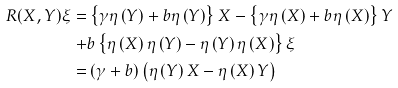Convert formula to latex. <formula><loc_0><loc_0><loc_500><loc_500>R ( X , Y ) \xi = & \left \{ \gamma \eta \left ( Y \right ) + b \eta \left ( Y \right ) \right \} X - \left \{ \gamma \eta \left ( X \right ) + b \eta \left ( X \right ) \right \} Y \\ + & b \left \{ \eta \left ( X \right ) \eta \left ( Y \right ) - \eta \left ( Y \right ) \eta \left ( X \right ) \right \} \xi \\ = & \left ( \gamma + b \right ) \left ( \eta \left ( Y \right ) X - \eta \left ( X \right ) Y \right )</formula> 